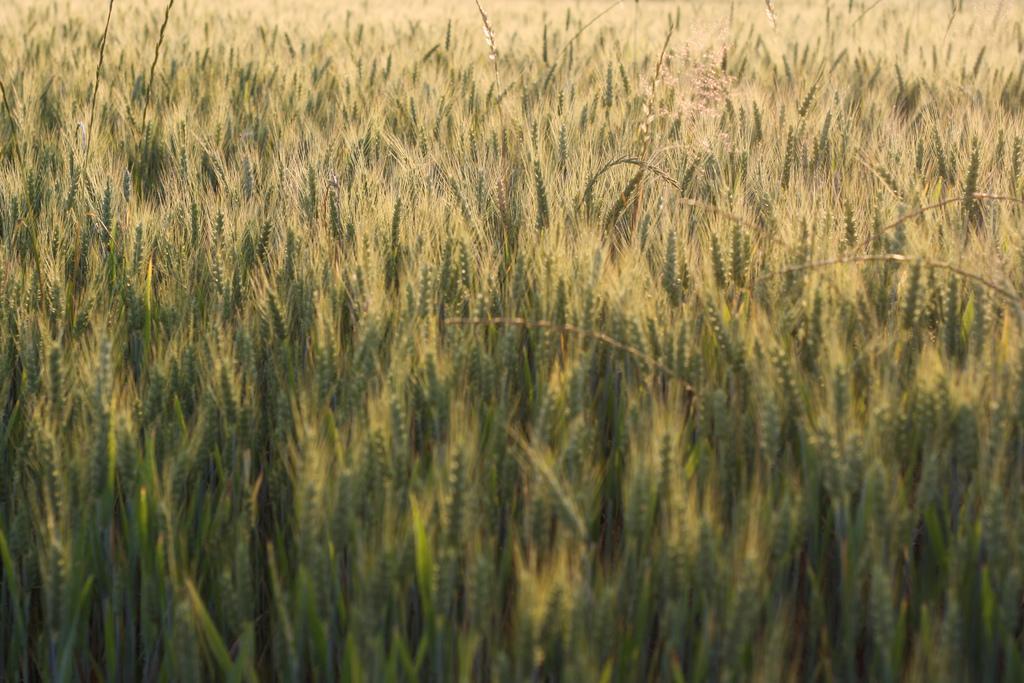How would you summarize this image in a sentence or two? In this image there is a wheat crop. 